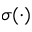Convert formula to latex. <formula><loc_0><loc_0><loc_500><loc_500>\sigma ( \cdot )</formula> 